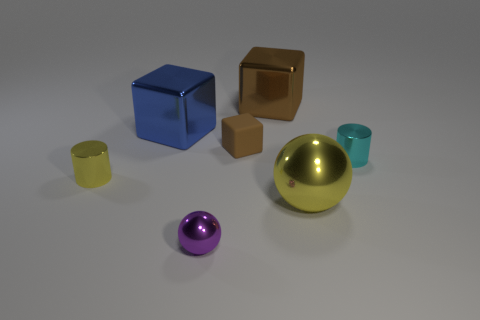Subtract all brown cubes. How many cubes are left? 1 Subtract all cyan balls. How many brown blocks are left? 2 Add 2 big blue cubes. How many objects exist? 9 Subtract all balls. How many objects are left? 5 Add 2 metallic spheres. How many metallic spheres are left? 4 Add 2 big yellow metal things. How many big yellow metal things exist? 3 Subtract 0 yellow blocks. How many objects are left? 7 Subtract all big yellow metallic objects. Subtract all large brown balls. How many objects are left? 6 